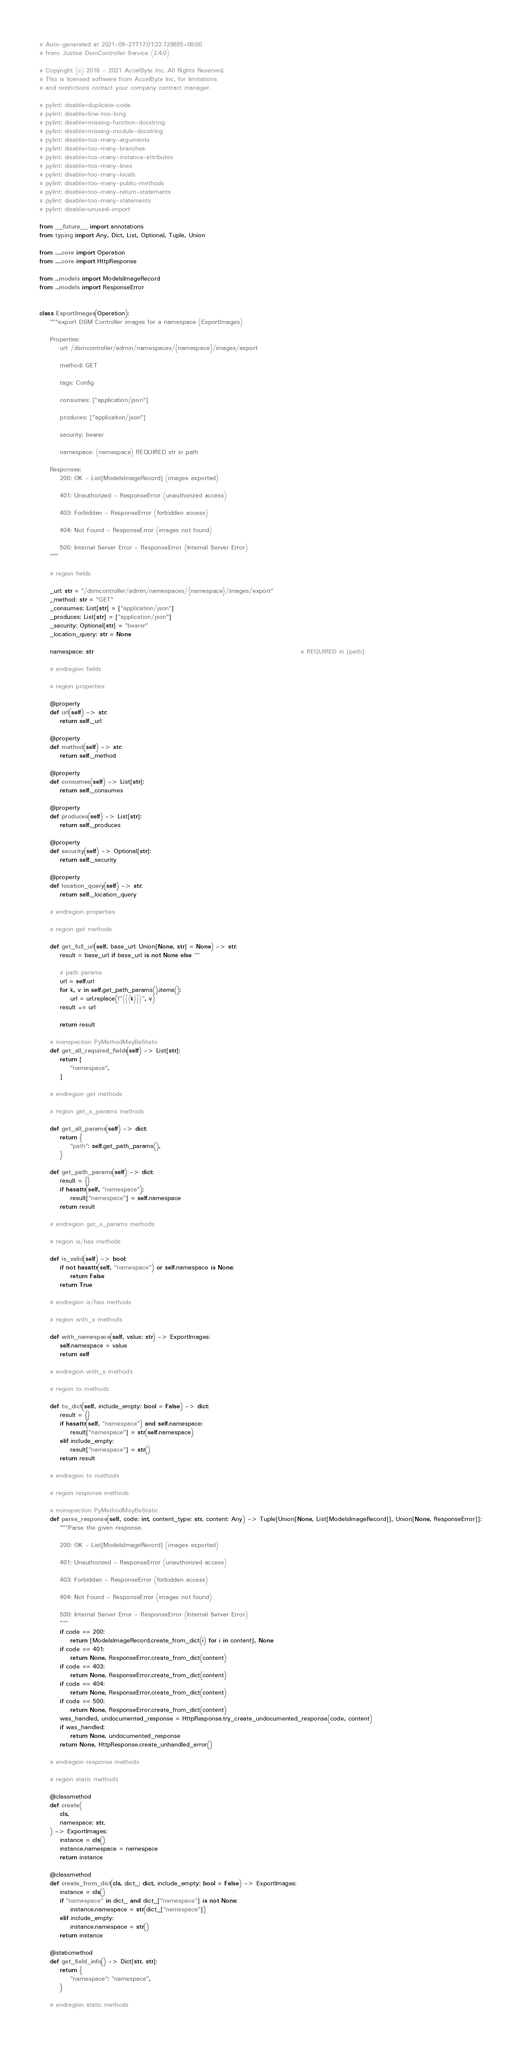<code> <loc_0><loc_0><loc_500><loc_500><_Python_># Auto-generated at 2021-09-27T17:01:22.729885+08:00
# from: Justice DsmController Service (2.4.0)

# Copyright (c) 2018 - 2021 AccelByte Inc. All Rights Reserved.
# This is licensed software from AccelByte Inc, for limitations
# and restrictions contact your company contract manager.

# pylint: disable=duplicate-code
# pylint: disable=line-too-long
# pylint: disable=missing-function-docstring
# pylint: disable=missing-module-docstring
# pylint: disable=too-many-arguments
# pylint: disable=too-many-branches
# pylint: disable=too-many-instance-attributes
# pylint: disable=too-many-lines
# pylint: disable=too-many-locals
# pylint: disable=too-many-public-methods
# pylint: disable=too-many-return-statements
# pylint: disable=too-many-statements
# pylint: disable=unused-import

from __future__ import annotations
from typing import Any, Dict, List, Optional, Tuple, Union

from .....core import Operation
from .....core import HttpResponse

from ...models import ModelsImageRecord
from ...models import ResponseError


class ExportImages(Operation):
    """export DSM Controller images for a namespace (ExportImages)

    Properties:
        url: /dsmcontroller/admin/namespaces/{namespace}/images/export

        method: GET

        tags: Config

        consumes: ["application/json"]

        produces: ["application/json"]

        security: bearer

        namespace: (namespace) REQUIRED str in path

    Responses:
        200: OK - List[ModelsImageRecord] (images exported)

        401: Unauthorized - ResponseError (unauthorized access)

        403: Forbidden - ResponseError (forbidden access)

        404: Not Found - ResponseError (images not found)

        500: Internal Server Error - ResponseError (Internal Server Error)
    """

    # region fields

    _url: str = "/dsmcontroller/admin/namespaces/{namespace}/images/export"
    _method: str = "GET"
    _consumes: List[str] = ["application/json"]
    _produces: List[str] = ["application/json"]
    _security: Optional[str] = "bearer"
    _location_query: str = None

    namespace: str                                                                                 # REQUIRED in [path]

    # endregion fields

    # region properties

    @property
    def url(self) -> str:
        return self._url

    @property
    def method(self) -> str:
        return self._method

    @property
    def consumes(self) -> List[str]:
        return self._consumes

    @property
    def produces(self) -> List[str]:
        return self._produces

    @property
    def security(self) -> Optional[str]:
        return self._security

    @property
    def location_query(self) -> str:
        return self._location_query

    # endregion properties

    # region get methods

    def get_full_url(self, base_url: Union[None, str] = None) -> str:
        result = base_url if base_url is not None else ""

        # path params
        url = self.url
        for k, v in self.get_path_params().items():
            url = url.replace(f"{{{k}}}", v)
        result += url

        return result

    # noinspection PyMethodMayBeStatic
    def get_all_required_fields(self) -> List[str]:
        return [
            "namespace",
        ]

    # endregion get methods

    # region get_x_params methods

    def get_all_params(self) -> dict:
        return {
            "path": self.get_path_params(),
        }

    def get_path_params(self) -> dict:
        result = {}
        if hasattr(self, "namespace"):
            result["namespace"] = self.namespace
        return result

    # endregion get_x_params methods

    # region is/has methods

    def is_valid(self) -> bool:
        if not hasattr(self, "namespace") or self.namespace is None:
            return False
        return True

    # endregion is/has methods

    # region with_x methods

    def with_namespace(self, value: str) -> ExportImages:
        self.namespace = value
        return self

    # endregion with_x methods

    # region to methods

    def to_dict(self, include_empty: bool = False) -> dict:
        result = {}
        if hasattr(self, "namespace") and self.namespace:
            result["namespace"] = str(self.namespace)
        elif include_empty:
            result["namespace"] = str()
        return result

    # endregion to methods

    # region response methods

    # noinspection PyMethodMayBeStatic
    def parse_response(self, code: int, content_type: str, content: Any) -> Tuple[Union[None, List[ModelsImageRecord]], Union[None, ResponseError]]:
        """Parse the given response.

        200: OK - List[ModelsImageRecord] (images exported)

        401: Unauthorized - ResponseError (unauthorized access)

        403: Forbidden - ResponseError (forbidden access)

        404: Not Found - ResponseError (images not found)

        500: Internal Server Error - ResponseError (Internal Server Error)
        """
        if code == 200:
            return [ModelsImageRecord.create_from_dict(i) for i in content], None
        if code == 401:
            return None, ResponseError.create_from_dict(content)
        if code == 403:
            return None, ResponseError.create_from_dict(content)
        if code == 404:
            return None, ResponseError.create_from_dict(content)
        if code == 500:
            return None, ResponseError.create_from_dict(content)
        was_handled, undocumented_response = HttpResponse.try_create_undocumented_response(code, content)
        if was_handled:
            return None, undocumented_response
        return None, HttpResponse.create_unhandled_error()

    # endregion response methods

    # region static methods

    @classmethod
    def create(
        cls,
        namespace: str,
    ) -> ExportImages:
        instance = cls()
        instance.namespace = namespace
        return instance

    @classmethod
    def create_from_dict(cls, dict_: dict, include_empty: bool = False) -> ExportImages:
        instance = cls()
        if "namespace" in dict_ and dict_["namespace"] is not None:
            instance.namespace = str(dict_["namespace"])
        elif include_empty:
            instance.namespace = str()
        return instance

    @staticmethod
    def get_field_info() -> Dict[str, str]:
        return {
            "namespace": "namespace",
        }

    # endregion static methods
</code> 